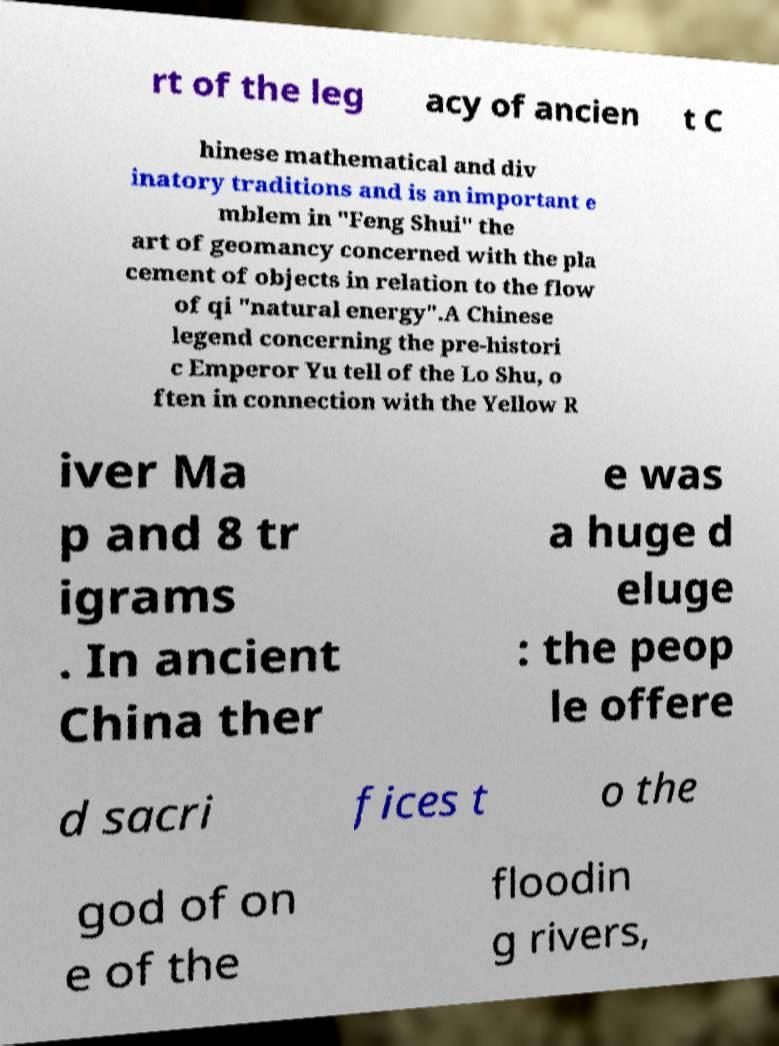What messages or text are displayed in this image? I need them in a readable, typed format. rt of the leg acy of ancien t C hinese mathematical and div inatory traditions and is an important e mblem in "Feng Shui" the art of geomancy concerned with the pla cement of objects in relation to the flow of qi "natural energy".A Chinese legend concerning the pre-histori c Emperor Yu tell of the Lo Shu, o ften in connection with the Yellow R iver Ma p and 8 tr igrams . In ancient China ther e was a huge d eluge : the peop le offere d sacri fices t o the god of on e of the floodin g rivers, 